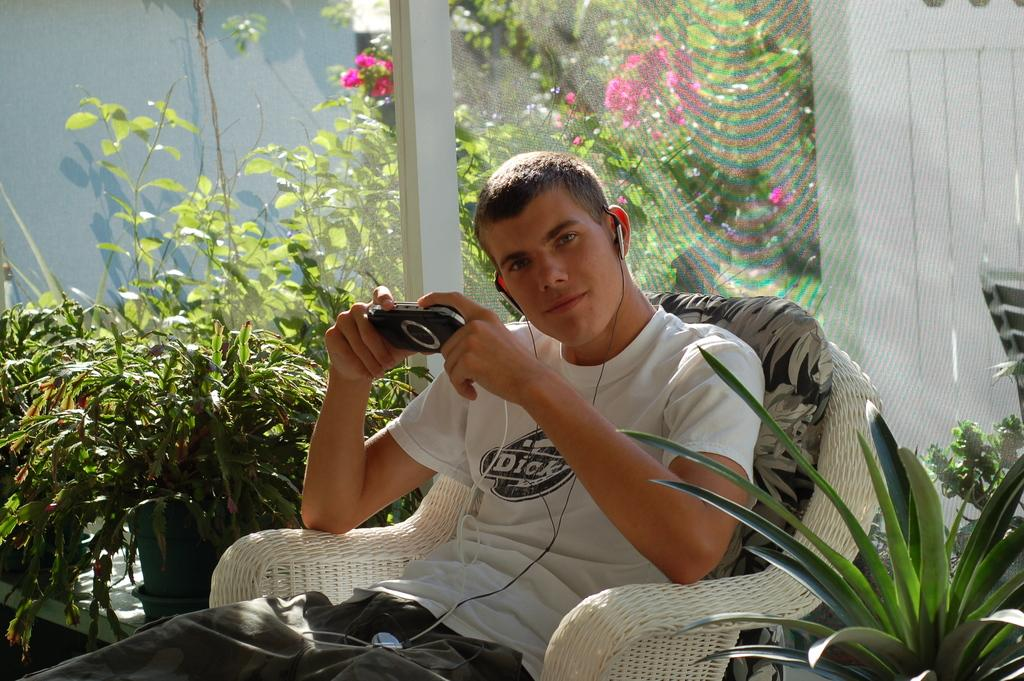Who is present in the image? There is a person in the image. What is the person doing in the image? The person is sitting on a chair. What object is the person holding in the image? The person is holding an iPod. How is the person listening to the iPod? The person has earphones in his ears. What can be seen in the background of the image? There are plants visible in the image. What type of pipe is the person smoking in the image? There is no pipe present in the image; the person is holding an iPod and has earphones in his ears. 